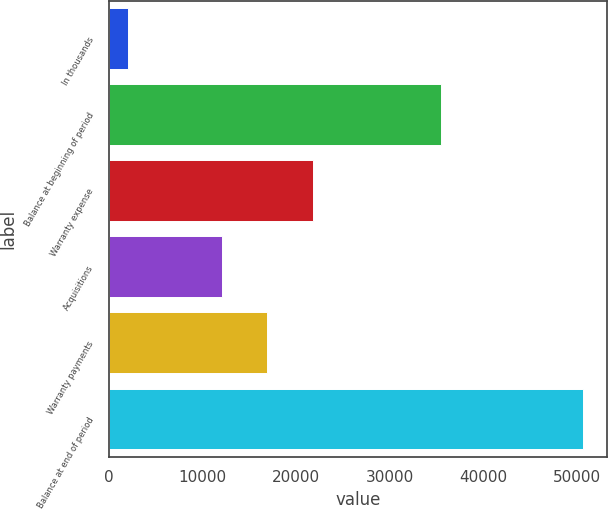Convert chart. <chart><loc_0><loc_0><loc_500><loc_500><bar_chart><fcel>In thousands<fcel>Balance at beginning of period<fcel>Warranty expense<fcel>Acquisitions<fcel>Warranty payments<fcel>Balance at end of period<nl><fcel>2011<fcel>35513<fcel>21795.8<fcel>12070<fcel>16932.9<fcel>50640<nl></chart> 